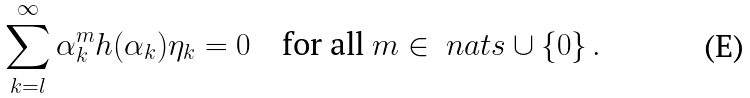Convert formula to latex. <formula><loc_0><loc_0><loc_500><loc_500>\sum _ { k = l } ^ { \infty } \alpha _ { k } ^ { m } h ( \alpha _ { k } ) \eta _ { k } = 0 \quad \text {for all } m \in \ n a t s \cup \{ 0 \} \, .</formula> 